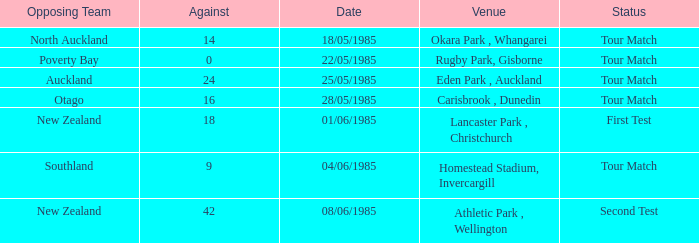On which date did the opposing team play against poverty bay? 22/05/1985. 